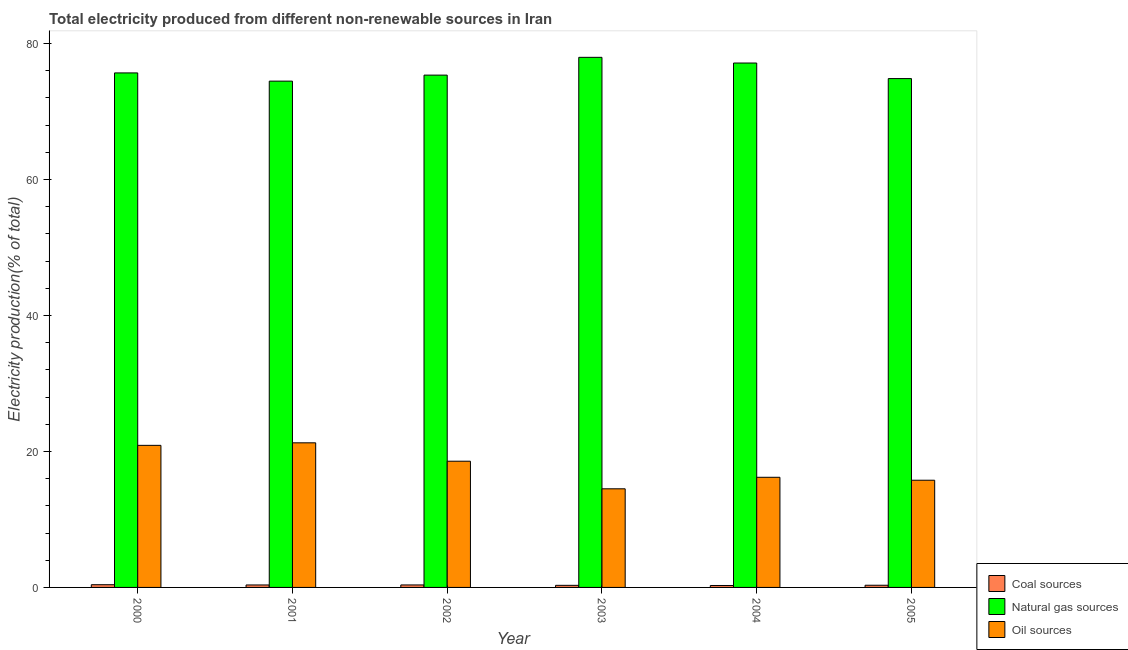How many bars are there on the 4th tick from the left?
Offer a terse response. 3. In how many cases, is the number of bars for a given year not equal to the number of legend labels?
Give a very brief answer. 0. What is the percentage of electricity produced by coal in 2003?
Provide a succinct answer. 0.31. Across all years, what is the maximum percentage of electricity produced by natural gas?
Provide a succinct answer. 77.96. Across all years, what is the minimum percentage of electricity produced by natural gas?
Your response must be concise. 74.46. In which year was the percentage of electricity produced by oil sources maximum?
Offer a terse response. 2001. What is the total percentage of electricity produced by oil sources in the graph?
Your response must be concise. 107.19. What is the difference between the percentage of electricity produced by natural gas in 2003 and that in 2005?
Your answer should be compact. 3.13. What is the difference between the percentage of electricity produced by coal in 2002 and the percentage of electricity produced by oil sources in 2005?
Keep it short and to the point. 0.05. What is the average percentage of electricity produced by oil sources per year?
Offer a terse response. 17.87. What is the ratio of the percentage of electricity produced by coal in 2000 to that in 2002?
Give a very brief answer. 1.09. Is the percentage of electricity produced by coal in 2004 less than that in 2005?
Offer a terse response. Yes. Is the difference between the percentage of electricity produced by coal in 2000 and 2004 greater than the difference between the percentage of electricity produced by natural gas in 2000 and 2004?
Provide a succinct answer. No. What is the difference between the highest and the second highest percentage of electricity produced by coal?
Offer a terse response. 0.03. What is the difference between the highest and the lowest percentage of electricity produced by natural gas?
Keep it short and to the point. 3.5. Is the sum of the percentage of electricity produced by oil sources in 2002 and 2003 greater than the maximum percentage of electricity produced by natural gas across all years?
Your response must be concise. Yes. What does the 2nd bar from the left in 2004 represents?
Your answer should be compact. Natural gas sources. What does the 1st bar from the right in 2002 represents?
Provide a short and direct response. Oil sources. How many years are there in the graph?
Your answer should be compact. 6. What is the difference between two consecutive major ticks on the Y-axis?
Provide a succinct answer. 20. Are the values on the major ticks of Y-axis written in scientific E-notation?
Ensure brevity in your answer.  No. Does the graph contain grids?
Make the answer very short. No. How many legend labels are there?
Provide a short and direct response. 3. What is the title of the graph?
Offer a terse response. Total electricity produced from different non-renewable sources in Iran. What is the Electricity production(% of total) in Coal sources in 2000?
Provide a short and direct response. 0.4. What is the Electricity production(% of total) of Natural gas sources in 2000?
Ensure brevity in your answer.  75.67. What is the Electricity production(% of total) in Oil sources in 2000?
Make the answer very short. 20.89. What is the Electricity production(% of total) in Coal sources in 2001?
Give a very brief answer. 0.36. What is the Electricity production(% of total) of Natural gas sources in 2001?
Your response must be concise. 74.46. What is the Electricity production(% of total) of Oil sources in 2001?
Your response must be concise. 21.27. What is the Electricity production(% of total) in Coal sources in 2002?
Make the answer very short. 0.37. What is the Electricity production(% of total) of Natural gas sources in 2002?
Provide a short and direct response. 75.34. What is the Electricity production(% of total) in Oil sources in 2002?
Give a very brief answer. 18.56. What is the Electricity production(% of total) in Coal sources in 2003?
Provide a short and direct response. 0.31. What is the Electricity production(% of total) in Natural gas sources in 2003?
Provide a succinct answer. 77.96. What is the Electricity production(% of total) of Oil sources in 2003?
Ensure brevity in your answer.  14.5. What is the Electricity production(% of total) of Coal sources in 2004?
Your response must be concise. 0.29. What is the Electricity production(% of total) of Natural gas sources in 2004?
Keep it short and to the point. 77.12. What is the Electricity production(% of total) in Oil sources in 2004?
Your answer should be compact. 16.2. What is the Electricity production(% of total) in Coal sources in 2005?
Provide a short and direct response. 0.32. What is the Electricity production(% of total) of Natural gas sources in 2005?
Ensure brevity in your answer.  74.83. What is the Electricity production(% of total) of Oil sources in 2005?
Offer a terse response. 15.77. Across all years, what is the maximum Electricity production(% of total) of Coal sources?
Provide a succinct answer. 0.4. Across all years, what is the maximum Electricity production(% of total) in Natural gas sources?
Your answer should be compact. 77.96. Across all years, what is the maximum Electricity production(% of total) of Oil sources?
Offer a very short reply. 21.27. Across all years, what is the minimum Electricity production(% of total) of Coal sources?
Your answer should be compact. 0.29. Across all years, what is the minimum Electricity production(% of total) in Natural gas sources?
Your response must be concise. 74.46. Across all years, what is the minimum Electricity production(% of total) of Oil sources?
Provide a succinct answer. 14.5. What is the total Electricity production(% of total) of Coal sources in the graph?
Keep it short and to the point. 2.04. What is the total Electricity production(% of total) of Natural gas sources in the graph?
Your answer should be compact. 455.39. What is the total Electricity production(% of total) in Oil sources in the graph?
Your response must be concise. 107.19. What is the difference between the Electricity production(% of total) of Coal sources in 2000 and that in 2001?
Your answer should be very brief. 0.04. What is the difference between the Electricity production(% of total) in Natural gas sources in 2000 and that in 2001?
Offer a terse response. 1.21. What is the difference between the Electricity production(% of total) in Oil sources in 2000 and that in 2001?
Ensure brevity in your answer.  -0.37. What is the difference between the Electricity production(% of total) of Coal sources in 2000 and that in 2002?
Your answer should be compact. 0.03. What is the difference between the Electricity production(% of total) of Natural gas sources in 2000 and that in 2002?
Ensure brevity in your answer.  0.32. What is the difference between the Electricity production(% of total) in Oil sources in 2000 and that in 2002?
Ensure brevity in your answer.  2.33. What is the difference between the Electricity production(% of total) of Coal sources in 2000 and that in 2003?
Provide a short and direct response. 0.09. What is the difference between the Electricity production(% of total) in Natural gas sources in 2000 and that in 2003?
Provide a short and direct response. -2.29. What is the difference between the Electricity production(% of total) of Oil sources in 2000 and that in 2003?
Make the answer very short. 6.39. What is the difference between the Electricity production(% of total) of Coal sources in 2000 and that in 2004?
Ensure brevity in your answer.  0.11. What is the difference between the Electricity production(% of total) of Natural gas sources in 2000 and that in 2004?
Your answer should be very brief. -1.46. What is the difference between the Electricity production(% of total) of Oil sources in 2000 and that in 2004?
Your response must be concise. 4.7. What is the difference between the Electricity production(% of total) in Coal sources in 2000 and that in 2005?
Offer a terse response. 0.08. What is the difference between the Electricity production(% of total) of Natural gas sources in 2000 and that in 2005?
Make the answer very short. 0.84. What is the difference between the Electricity production(% of total) in Oil sources in 2000 and that in 2005?
Keep it short and to the point. 5.13. What is the difference between the Electricity production(% of total) in Coal sources in 2001 and that in 2002?
Offer a terse response. -0. What is the difference between the Electricity production(% of total) in Natural gas sources in 2001 and that in 2002?
Keep it short and to the point. -0.88. What is the difference between the Electricity production(% of total) of Oil sources in 2001 and that in 2002?
Offer a very short reply. 2.7. What is the difference between the Electricity production(% of total) of Coal sources in 2001 and that in 2003?
Give a very brief answer. 0.06. What is the difference between the Electricity production(% of total) in Natural gas sources in 2001 and that in 2003?
Your answer should be very brief. -3.5. What is the difference between the Electricity production(% of total) in Oil sources in 2001 and that in 2003?
Make the answer very short. 6.76. What is the difference between the Electricity production(% of total) of Coal sources in 2001 and that in 2004?
Offer a terse response. 0.08. What is the difference between the Electricity production(% of total) in Natural gas sources in 2001 and that in 2004?
Give a very brief answer. -2.66. What is the difference between the Electricity production(% of total) of Oil sources in 2001 and that in 2004?
Make the answer very short. 5.07. What is the difference between the Electricity production(% of total) of Coal sources in 2001 and that in 2005?
Your answer should be very brief. 0.04. What is the difference between the Electricity production(% of total) of Natural gas sources in 2001 and that in 2005?
Provide a succinct answer. -0.37. What is the difference between the Electricity production(% of total) of Oil sources in 2001 and that in 2005?
Ensure brevity in your answer.  5.5. What is the difference between the Electricity production(% of total) of Coal sources in 2002 and that in 2003?
Provide a succinct answer. 0.06. What is the difference between the Electricity production(% of total) of Natural gas sources in 2002 and that in 2003?
Your answer should be compact. -2.62. What is the difference between the Electricity production(% of total) in Oil sources in 2002 and that in 2003?
Offer a terse response. 4.06. What is the difference between the Electricity production(% of total) of Coal sources in 2002 and that in 2004?
Make the answer very short. 0.08. What is the difference between the Electricity production(% of total) in Natural gas sources in 2002 and that in 2004?
Offer a very short reply. -1.78. What is the difference between the Electricity production(% of total) of Oil sources in 2002 and that in 2004?
Offer a terse response. 2.37. What is the difference between the Electricity production(% of total) of Coal sources in 2002 and that in 2005?
Make the answer very short. 0.05. What is the difference between the Electricity production(% of total) in Natural gas sources in 2002 and that in 2005?
Your answer should be compact. 0.51. What is the difference between the Electricity production(% of total) in Oil sources in 2002 and that in 2005?
Keep it short and to the point. 2.8. What is the difference between the Electricity production(% of total) of Coal sources in 2003 and that in 2004?
Your answer should be compact. 0.02. What is the difference between the Electricity production(% of total) of Natural gas sources in 2003 and that in 2004?
Offer a terse response. 0.84. What is the difference between the Electricity production(% of total) of Oil sources in 2003 and that in 2004?
Your answer should be compact. -1.69. What is the difference between the Electricity production(% of total) in Coal sources in 2003 and that in 2005?
Make the answer very short. -0.01. What is the difference between the Electricity production(% of total) of Natural gas sources in 2003 and that in 2005?
Offer a terse response. 3.13. What is the difference between the Electricity production(% of total) in Oil sources in 2003 and that in 2005?
Your answer should be very brief. -1.26. What is the difference between the Electricity production(% of total) of Coal sources in 2004 and that in 2005?
Your answer should be compact. -0.04. What is the difference between the Electricity production(% of total) of Natural gas sources in 2004 and that in 2005?
Give a very brief answer. 2.29. What is the difference between the Electricity production(% of total) in Oil sources in 2004 and that in 2005?
Provide a succinct answer. 0.43. What is the difference between the Electricity production(% of total) in Coal sources in 2000 and the Electricity production(% of total) in Natural gas sources in 2001?
Your answer should be very brief. -74.06. What is the difference between the Electricity production(% of total) of Coal sources in 2000 and the Electricity production(% of total) of Oil sources in 2001?
Keep it short and to the point. -20.87. What is the difference between the Electricity production(% of total) of Natural gas sources in 2000 and the Electricity production(% of total) of Oil sources in 2001?
Make the answer very short. 54.4. What is the difference between the Electricity production(% of total) of Coal sources in 2000 and the Electricity production(% of total) of Natural gas sources in 2002?
Give a very brief answer. -74.94. What is the difference between the Electricity production(% of total) in Coal sources in 2000 and the Electricity production(% of total) in Oil sources in 2002?
Your answer should be very brief. -18.16. What is the difference between the Electricity production(% of total) in Natural gas sources in 2000 and the Electricity production(% of total) in Oil sources in 2002?
Your answer should be very brief. 57.11. What is the difference between the Electricity production(% of total) in Coal sources in 2000 and the Electricity production(% of total) in Natural gas sources in 2003?
Keep it short and to the point. -77.56. What is the difference between the Electricity production(% of total) of Coal sources in 2000 and the Electricity production(% of total) of Oil sources in 2003?
Your answer should be compact. -14.1. What is the difference between the Electricity production(% of total) in Natural gas sources in 2000 and the Electricity production(% of total) in Oil sources in 2003?
Your response must be concise. 61.16. What is the difference between the Electricity production(% of total) in Coal sources in 2000 and the Electricity production(% of total) in Natural gas sources in 2004?
Offer a terse response. -76.72. What is the difference between the Electricity production(% of total) of Coal sources in 2000 and the Electricity production(% of total) of Oil sources in 2004?
Offer a very short reply. -15.8. What is the difference between the Electricity production(% of total) of Natural gas sources in 2000 and the Electricity production(% of total) of Oil sources in 2004?
Your response must be concise. 59.47. What is the difference between the Electricity production(% of total) of Coal sources in 2000 and the Electricity production(% of total) of Natural gas sources in 2005?
Your answer should be compact. -74.43. What is the difference between the Electricity production(% of total) of Coal sources in 2000 and the Electricity production(% of total) of Oil sources in 2005?
Offer a very short reply. -15.37. What is the difference between the Electricity production(% of total) of Natural gas sources in 2000 and the Electricity production(% of total) of Oil sources in 2005?
Your answer should be very brief. 59.9. What is the difference between the Electricity production(% of total) in Coal sources in 2001 and the Electricity production(% of total) in Natural gas sources in 2002?
Provide a succinct answer. -74.98. What is the difference between the Electricity production(% of total) in Coal sources in 2001 and the Electricity production(% of total) in Oil sources in 2002?
Offer a very short reply. -18.2. What is the difference between the Electricity production(% of total) in Natural gas sources in 2001 and the Electricity production(% of total) in Oil sources in 2002?
Give a very brief answer. 55.9. What is the difference between the Electricity production(% of total) in Coal sources in 2001 and the Electricity production(% of total) in Natural gas sources in 2003?
Give a very brief answer. -77.6. What is the difference between the Electricity production(% of total) in Coal sources in 2001 and the Electricity production(% of total) in Oil sources in 2003?
Your answer should be compact. -14.14. What is the difference between the Electricity production(% of total) in Natural gas sources in 2001 and the Electricity production(% of total) in Oil sources in 2003?
Your answer should be compact. 59.96. What is the difference between the Electricity production(% of total) in Coal sources in 2001 and the Electricity production(% of total) in Natural gas sources in 2004?
Give a very brief answer. -76.76. What is the difference between the Electricity production(% of total) in Coal sources in 2001 and the Electricity production(% of total) in Oil sources in 2004?
Keep it short and to the point. -15.83. What is the difference between the Electricity production(% of total) of Natural gas sources in 2001 and the Electricity production(% of total) of Oil sources in 2004?
Offer a very short reply. 58.26. What is the difference between the Electricity production(% of total) of Coal sources in 2001 and the Electricity production(% of total) of Natural gas sources in 2005?
Offer a very short reply. -74.47. What is the difference between the Electricity production(% of total) in Coal sources in 2001 and the Electricity production(% of total) in Oil sources in 2005?
Provide a short and direct response. -15.4. What is the difference between the Electricity production(% of total) in Natural gas sources in 2001 and the Electricity production(% of total) in Oil sources in 2005?
Provide a short and direct response. 58.69. What is the difference between the Electricity production(% of total) of Coal sources in 2002 and the Electricity production(% of total) of Natural gas sources in 2003?
Offer a very short reply. -77.59. What is the difference between the Electricity production(% of total) in Coal sources in 2002 and the Electricity production(% of total) in Oil sources in 2003?
Your response must be concise. -14.14. What is the difference between the Electricity production(% of total) in Natural gas sources in 2002 and the Electricity production(% of total) in Oil sources in 2003?
Provide a succinct answer. 60.84. What is the difference between the Electricity production(% of total) in Coal sources in 2002 and the Electricity production(% of total) in Natural gas sources in 2004?
Keep it short and to the point. -76.76. What is the difference between the Electricity production(% of total) in Coal sources in 2002 and the Electricity production(% of total) in Oil sources in 2004?
Your answer should be very brief. -15.83. What is the difference between the Electricity production(% of total) of Natural gas sources in 2002 and the Electricity production(% of total) of Oil sources in 2004?
Offer a terse response. 59.15. What is the difference between the Electricity production(% of total) of Coal sources in 2002 and the Electricity production(% of total) of Natural gas sources in 2005?
Provide a short and direct response. -74.47. What is the difference between the Electricity production(% of total) of Coal sources in 2002 and the Electricity production(% of total) of Oil sources in 2005?
Your response must be concise. -15.4. What is the difference between the Electricity production(% of total) of Natural gas sources in 2002 and the Electricity production(% of total) of Oil sources in 2005?
Your answer should be compact. 59.58. What is the difference between the Electricity production(% of total) in Coal sources in 2003 and the Electricity production(% of total) in Natural gas sources in 2004?
Your answer should be compact. -76.82. What is the difference between the Electricity production(% of total) in Coal sources in 2003 and the Electricity production(% of total) in Oil sources in 2004?
Your response must be concise. -15.89. What is the difference between the Electricity production(% of total) of Natural gas sources in 2003 and the Electricity production(% of total) of Oil sources in 2004?
Provide a short and direct response. 61.76. What is the difference between the Electricity production(% of total) in Coal sources in 2003 and the Electricity production(% of total) in Natural gas sources in 2005?
Your answer should be very brief. -74.53. What is the difference between the Electricity production(% of total) in Coal sources in 2003 and the Electricity production(% of total) in Oil sources in 2005?
Offer a very short reply. -15.46. What is the difference between the Electricity production(% of total) of Natural gas sources in 2003 and the Electricity production(% of total) of Oil sources in 2005?
Your response must be concise. 62.19. What is the difference between the Electricity production(% of total) in Coal sources in 2004 and the Electricity production(% of total) in Natural gas sources in 2005?
Give a very brief answer. -74.55. What is the difference between the Electricity production(% of total) in Coal sources in 2004 and the Electricity production(% of total) in Oil sources in 2005?
Your response must be concise. -15.48. What is the difference between the Electricity production(% of total) in Natural gas sources in 2004 and the Electricity production(% of total) in Oil sources in 2005?
Provide a succinct answer. 61.36. What is the average Electricity production(% of total) of Coal sources per year?
Offer a very short reply. 0.34. What is the average Electricity production(% of total) of Natural gas sources per year?
Your answer should be very brief. 75.9. What is the average Electricity production(% of total) of Oil sources per year?
Provide a short and direct response. 17.87. In the year 2000, what is the difference between the Electricity production(% of total) in Coal sources and Electricity production(% of total) in Natural gas sources?
Your answer should be very brief. -75.27. In the year 2000, what is the difference between the Electricity production(% of total) of Coal sources and Electricity production(% of total) of Oil sources?
Provide a succinct answer. -20.5. In the year 2000, what is the difference between the Electricity production(% of total) in Natural gas sources and Electricity production(% of total) in Oil sources?
Give a very brief answer. 54.77. In the year 2001, what is the difference between the Electricity production(% of total) of Coal sources and Electricity production(% of total) of Natural gas sources?
Offer a very short reply. -74.1. In the year 2001, what is the difference between the Electricity production(% of total) in Coal sources and Electricity production(% of total) in Oil sources?
Provide a succinct answer. -20.9. In the year 2001, what is the difference between the Electricity production(% of total) of Natural gas sources and Electricity production(% of total) of Oil sources?
Offer a terse response. 53.19. In the year 2002, what is the difference between the Electricity production(% of total) in Coal sources and Electricity production(% of total) in Natural gas sources?
Keep it short and to the point. -74.98. In the year 2002, what is the difference between the Electricity production(% of total) of Coal sources and Electricity production(% of total) of Oil sources?
Offer a very short reply. -18.2. In the year 2002, what is the difference between the Electricity production(% of total) in Natural gas sources and Electricity production(% of total) in Oil sources?
Offer a very short reply. 56.78. In the year 2003, what is the difference between the Electricity production(% of total) in Coal sources and Electricity production(% of total) in Natural gas sources?
Your answer should be very brief. -77.65. In the year 2003, what is the difference between the Electricity production(% of total) of Coal sources and Electricity production(% of total) of Oil sources?
Offer a terse response. -14.2. In the year 2003, what is the difference between the Electricity production(% of total) of Natural gas sources and Electricity production(% of total) of Oil sources?
Give a very brief answer. 63.46. In the year 2004, what is the difference between the Electricity production(% of total) in Coal sources and Electricity production(% of total) in Natural gas sources?
Provide a succinct answer. -76.84. In the year 2004, what is the difference between the Electricity production(% of total) in Coal sources and Electricity production(% of total) in Oil sources?
Give a very brief answer. -15.91. In the year 2004, what is the difference between the Electricity production(% of total) of Natural gas sources and Electricity production(% of total) of Oil sources?
Provide a succinct answer. 60.93. In the year 2005, what is the difference between the Electricity production(% of total) of Coal sources and Electricity production(% of total) of Natural gas sources?
Provide a succinct answer. -74.51. In the year 2005, what is the difference between the Electricity production(% of total) of Coal sources and Electricity production(% of total) of Oil sources?
Your answer should be compact. -15.45. In the year 2005, what is the difference between the Electricity production(% of total) in Natural gas sources and Electricity production(% of total) in Oil sources?
Keep it short and to the point. 59.07. What is the ratio of the Electricity production(% of total) in Coal sources in 2000 to that in 2001?
Your response must be concise. 1.1. What is the ratio of the Electricity production(% of total) of Natural gas sources in 2000 to that in 2001?
Your answer should be compact. 1.02. What is the ratio of the Electricity production(% of total) of Oil sources in 2000 to that in 2001?
Ensure brevity in your answer.  0.98. What is the ratio of the Electricity production(% of total) in Coal sources in 2000 to that in 2002?
Offer a terse response. 1.09. What is the ratio of the Electricity production(% of total) of Oil sources in 2000 to that in 2002?
Offer a terse response. 1.13. What is the ratio of the Electricity production(% of total) of Coal sources in 2000 to that in 2003?
Offer a terse response. 1.3. What is the ratio of the Electricity production(% of total) in Natural gas sources in 2000 to that in 2003?
Provide a short and direct response. 0.97. What is the ratio of the Electricity production(% of total) of Oil sources in 2000 to that in 2003?
Provide a succinct answer. 1.44. What is the ratio of the Electricity production(% of total) of Coal sources in 2000 to that in 2004?
Keep it short and to the point. 1.4. What is the ratio of the Electricity production(% of total) of Natural gas sources in 2000 to that in 2004?
Give a very brief answer. 0.98. What is the ratio of the Electricity production(% of total) in Oil sources in 2000 to that in 2004?
Ensure brevity in your answer.  1.29. What is the ratio of the Electricity production(% of total) of Coal sources in 2000 to that in 2005?
Give a very brief answer. 1.24. What is the ratio of the Electricity production(% of total) in Natural gas sources in 2000 to that in 2005?
Your answer should be compact. 1.01. What is the ratio of the Electricity production(% of total) in Oil sources in 2000 to that in 2005?
Keep it short and to the point. 1.33. What is the ratio of the Electricity production(% of total) of Natural gas sources in 2001 to that in 2002?
Make the answer very short. 0.99. What is the ratio of the Electricity production(% of total) of Oil sources in 2001 to that in 2002?
Give a very brief answer. 1.15. What is the ratio of the Electricity production(% of total) of Coal sources in 2001 to that in 2003?
Your response must be concise. 1.18. What is the ratio of the Electricity production(% of total) in Natural gas sources in 2001 to that in 2003?
Keep it short and to the point. 0.96. What is the ratio of the Electricity production(% of total) of Oil sources in 2001 to that in 2003?
Provide a succinct answer. 1.47. What is the ratio of the Electricity production(% of total) of Coal sources in 2001 to that in 2004?
Provide a short and direct response. 1.27. What is the ratio of the Electricity production(% of total) in Natural gas sources in 2001 to that in 2004?
Your answer should be very brief. 0.97. What is the ratio of the Electricity production(% of total) of Oil sources in 2001 to that in 2004?
Give a very brief answer. 1.31. What is the ratio of the Electricity production(% of total) of Coal sources in 2001 to that in 2005?
Provide a short and direct response. 1.13. What is the ratio of the Electricity production(% of total) of Natural gas sources in 2001 to that in 2005?
Provide a short and direct response. 0.99. What is the ratio of the Electricity production(% of total) in Oil sources in 2001 to that in 2005?
Make the answer very short. 1.35. What is the ratio of the Electricity production(% of total) in Coal sources in 2002 to that in 2003?
Give a very brief answer. 1.19. What is the ratio of the Electricity production(% of total) of Natural gas sources in 2002 to that in 2003?
Offer a very short reply. 0.97. What is the ratio of the Electricity production(% of total) of Oil sources in 2002 to that in 2003?
Give a very brief answer. 1.28. What is the ratio of the Electricity production(% of total) in Coal sources in 2002 to that in 2004?
Provide a succinct answer. 1.28. What is the ratio of the Electricity production(% of total) of Natural gas sources in 2002 to that in 2004?
Make the answer very short. 0.98. What is the ratio of the Electricity production(% of total) of Oil sources in 2002 to that in 2004?
Offer a very short reply. 1.15. What is the ratio of the Electricity production(% of total) of Coal sources in 2002 to that in 2005?
Make the answer very short. 1.14. What is the ratio of the Electricity production(% of total) in Natural gas sources in 2002 to that in 2005?
Ensure brevity in your answer.  1.01. What is the ratio of the Electricity production(% of total) of Oil sources in 2002 to that in 2005?
Provide a short and direct response. 1.18. What is the ratio of the Electricity production(% of total) of Coal sources in 2003 to that in 2004?
Give a very brief answer. 1.08. What is the ratio of the Electricity production(% of total) in Natural gas sources in 2003 to that in 2004?
Your response must be concise. 1.01. What is the ratio of the Electricity production(% of total) in Oil sources in 2003 to that in 2004?
Your answer should be compact. 0.9. What is the ratio of the Electricity production(% of total) in Coal sources in 2003 to that in 2005?
Provide a succinct answer. 0.96. What is the ratio of the Electricity production(% of total) in Natural gas sources in 2003 to that in 2005?
Your answer should be compact. 1.04. What is the ratio of the Electricity production(% of total) of Oil sources in 2003 to that in 2005?
Ensure brevity in your answer.  0.92. What is the ratio of the Electricity production(% of total) of Coal sources in 2004 to that in 2005?
Your response must be concise. 0.89. What is the ratio of the Electricity production(% of total) of Natural gas sources in 2004 to that in 2005?
Keep it short and to the point. 1.03. What is the ratio of the Electricity production(% of total) in Oil sources in 2004 to that in 2005?
Offer a terse response. 1.03. What is the difference between the highest and the second highest Electricity production(% of total) in Coal sources?
Make the answer very short. 0.03. What is the difference between the highest and the second highest Electricity production(% of total) of Natural gas sources?
Provide a short and direct response. 0.84. What is the difference between the highest and the second highest Electricity production(% of total) in Oil sources?
Your answer should be very brief. 0.37. What is the difference between the highest and the lowest Electricity production(% of total) of Coal sources?
Make the answer very short. 0.11. What is the difference between the highest and the lowest Electricity production(% of total) in Natural gas sources?
Give a very brief answer. 3.5. What is the difference between the highest and the lowest Electricity production(% of total) of Oil sources?
Offer a very short reply. 6.76. 